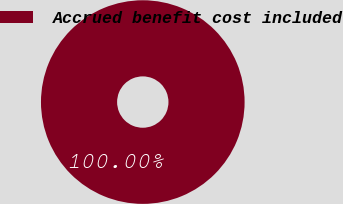Convert chart. <chart><loc_0><loc_0><loc_500><loc_500><pie_chart><fcel>Accrued benefit cost included<nl><fcel>100.0%<nl></chart> 